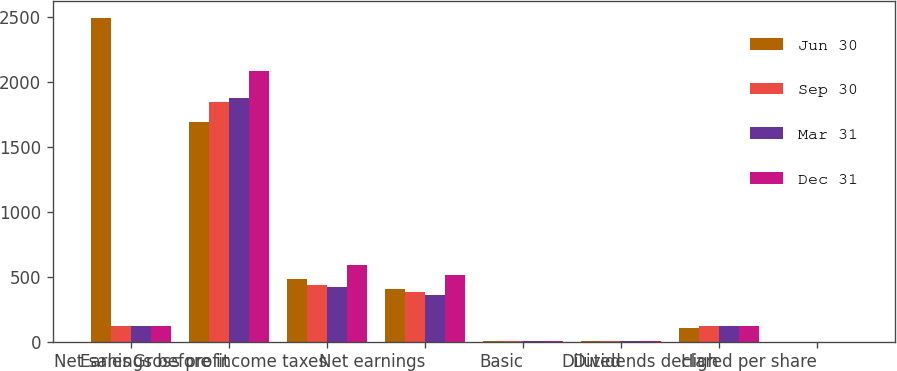<chart> <loc_0><loc_0><loc_500><loc_500><stacked_bar_chart><ecel><fcel>Net sales<fcel>Gross profit<fcel>Earnings before income taxes<fcel>Net earnings<fcel>Basic<fcel>Diluted<fcel>High<fcel>Dividends declared per share<nl><fcel>Jun 30<fcel>2495<fcel>1694<fcel>481<fcel>402<fcel>1.08<fcel>1.07<fcel>107.95<fcel>0.38<nl><fcel>Sep 30<fcel>121.84<fcel>1842<fcel>433<fcel>380<fcel>1.02<fcel>1<fcel>119.83<fcel>0.38<nl><fcel>Mar 31<fcel>121.84<fcel>1873<fcel>419<fcel>355<fcel>0.95<fcel>0.94<fcel>123.55<fcel>0.38<nl><fcel>Dec 31<fcel>121.84<fcel>2086<fcel>588<fcel>510<fcel>1.36<fcel>1.34<fcel>121.84<fcel>0.42<nl></chart> 